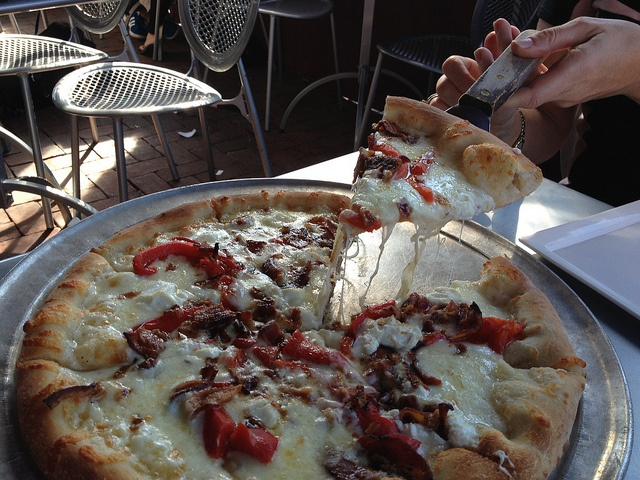Describe the objects in this image and their specific colors. I can see dining table in black, gray, maroon, and darkgray tones, pizza in black, gray, maroon, and darkgray tones, people in black, gray, and maroon tones, chair in black, gray, white, and darkgray tones, and chair in black, gray, white, and darkgray tones in this image. 